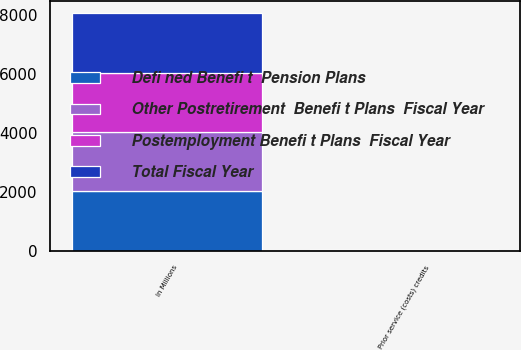Convert chart to OTSL. <chart><loc_0><loc_0><loc_500><loc_500><stacked_bar_chart><ecel><fcel>In Millions<fcel>Prior service (costs) credits<nl><fcel>Other Postretirement  Benefi t Plans  Fiscal Year<fcel>2015<fcel>13.8<nl><fcel>Defi ned Benefi t  Pension Plans<fcel>2015<fcel>23.8<nl><fcel>Postemployment Benefi t Plans  Fiscal Year<fcel>2015<fcel>2.9<nl><fcel>Total Fiscal Year<fcel>2015<fcel>7.1<nl></chart> 